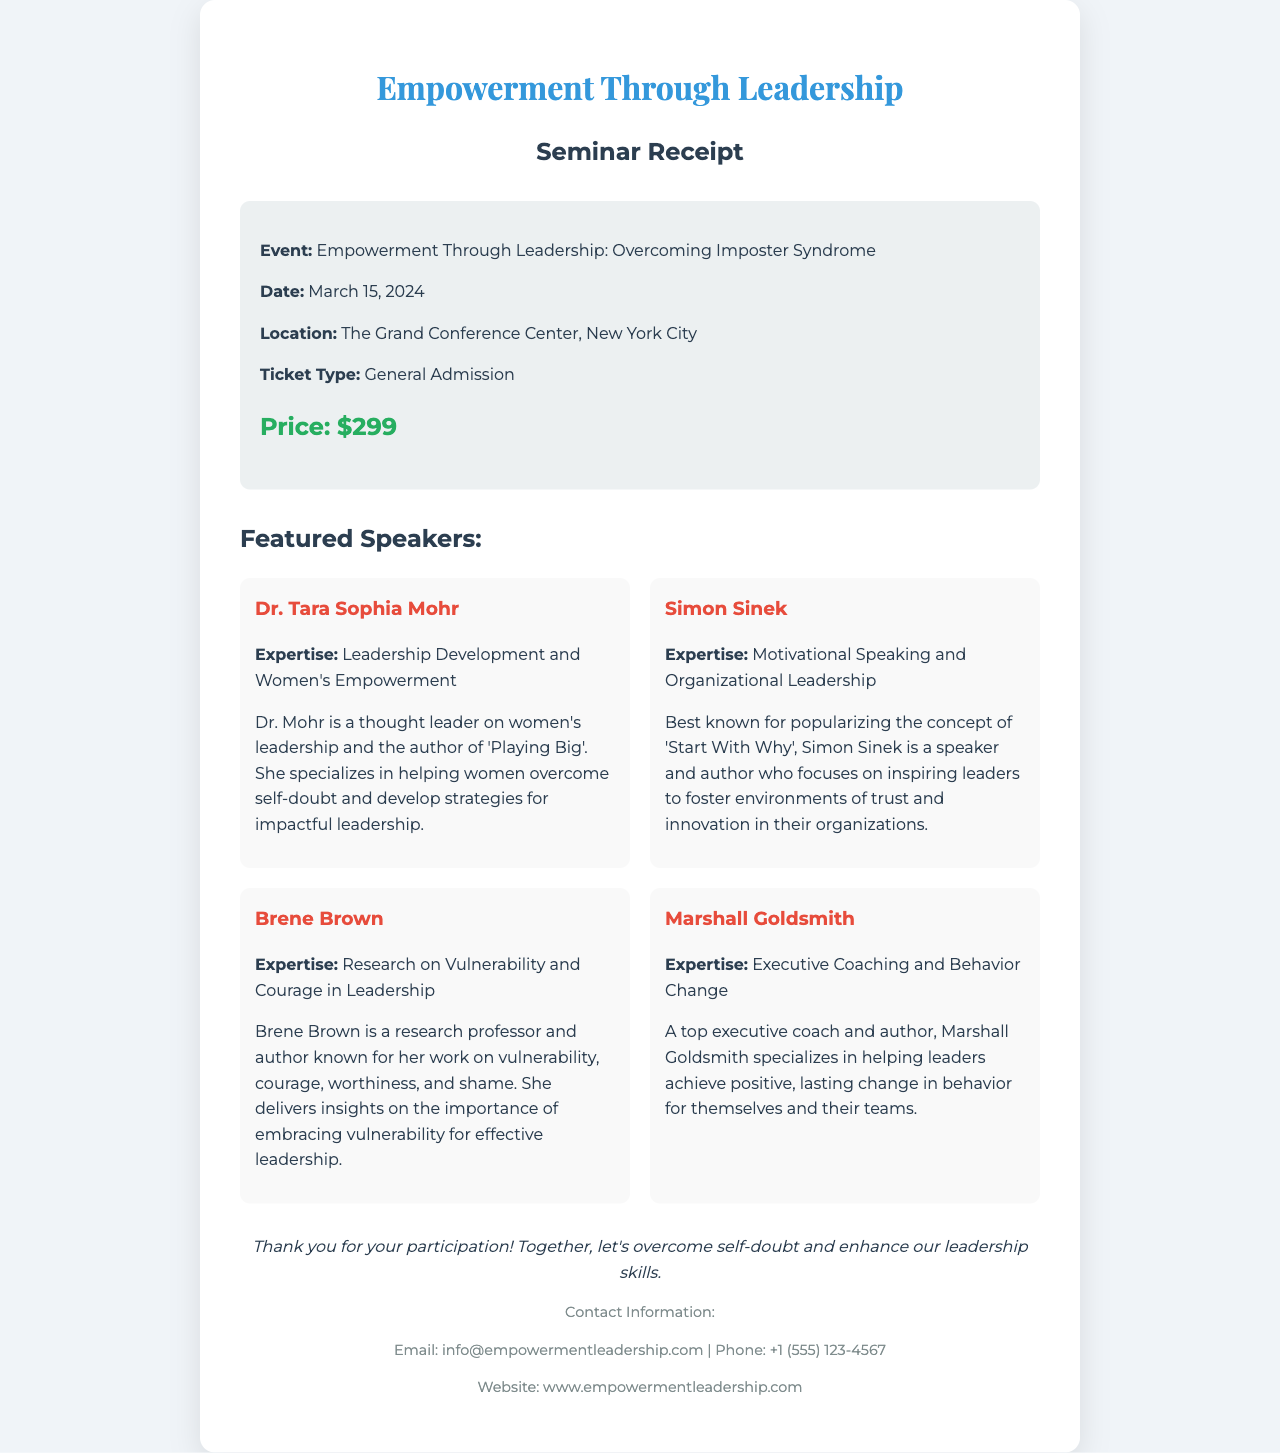What is the title of the seminar? The title of the seminar is explicitly stated in the document as "Empowerment Through Leadership: Overcoming Imposter Syndrome."
Answer: Empowerment Through Leadership: Overcoming Imposter Syndrome Who is the keynote speaker focused on women's empowerment? The document lists Dr. Tara Sophia Mohr as the speaker with expertise in Leadership Development and Women's Empowerment.
Answer: Dr. Tara Sophia Mohr What is the date of the seminar? The document specifies the date of the event as March 15, 2024.
Answer: March 15, 2024 How much is the general admission ticket? The price for the general admission ticket is highlighted in the document as $299.
Answer: $299 Which speaker specializes in executive coaching? The document identifies Marshall Goldsmith as the speaker who specializes in Executive Coaching and Behavior Change.
Answer: Marshall Goldsmith What location is the seminar being held at? The venue for the seminar is stated in the document as The Grand Conference Center, New York City.
Answer: The Grand Conference Center, New York City How many featured speakers are listed in the document? The document lists four featured speakers for the seminar.
Answer: Four What expertise does Brene Brown have? The document describes Brene Brown's expertise as Research on Vulnerability and Courage in Leadership.
Answer: Research on Vulnerability and Courage in Leadership What is the purpose of the seminar as stated in the note? The note explicitly mentions the purpose of the seminar is to "overcome self-doubt and enhance our leadership skills."
Answer: Overcome self-doubt and enhance our leadership skills 